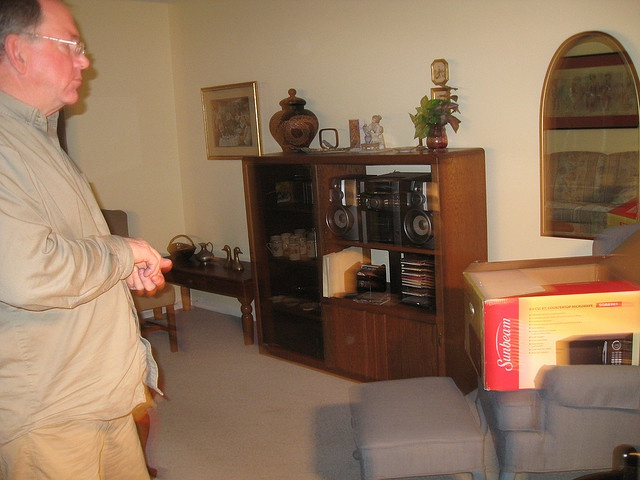Describe the objects in this image and their specific colors. I can see people in black, tan, and salmon tones, microwave in black, khaki, gold, tan, and salmon tones, couch in black, gray, and maroon tones, couch in black, maroon, and gray tones, and chair in black, maroon, and gray tones in this image. 